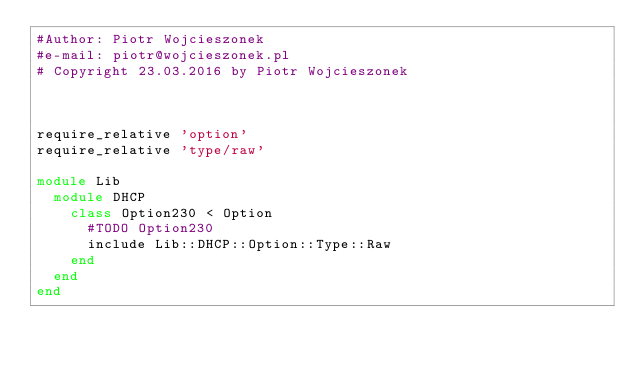<code> <loc_0><loc_0><loc_500><loc_500><_Ruby_>#Author: Piotr Wojcieszonek
#e-mail: piotr@wojcieszonek.pl
# Copyright 23.03.2016 by Piotr Wojcieszonek



require_relative 'option'
require_relative 'type/raw'

module Lib
  module DHCP
    class Option230 < Option
      #TODO Option230
      include Lib::DHCP::Option::Type::Raw
    end
  end
end
</code> 